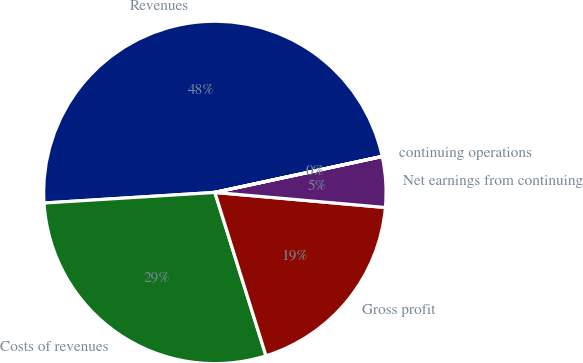Convert chart to OTSL. <chart><loc_0><loc_0><loc_500><loc_500><pie_chart><fcel>Revenues<fcel>Costs of revenues<fcel>Gross profit<fcel>Net earnings from continuing<fcel>continuing operations<nl><fcel>47.61%<fcel>28.84%<fcel>18.77%<fcel>4.77%<fcel>0.01%<nl></chart> 